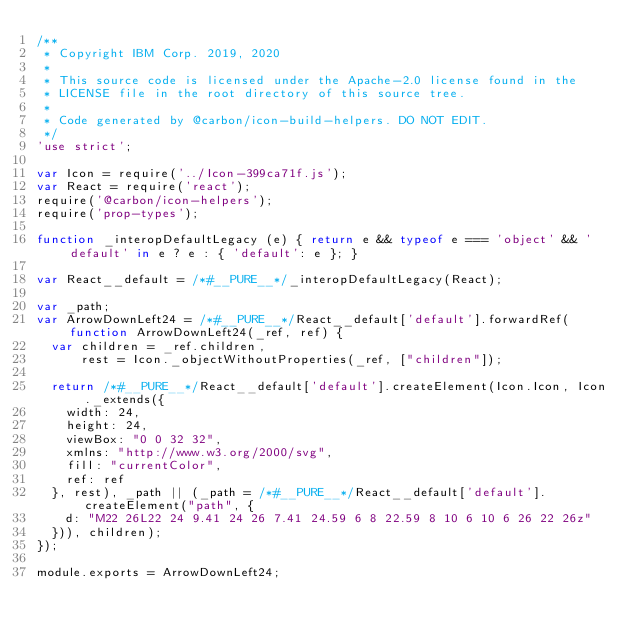Convert code to text. <code><loc_0><loc_0><loc_500><loc_500><_JavaScript_>/**
 * Copyright IBM Corp. 2019, 2020
 *
 * This source code is licensed under the Apache-2.0 license found in the
 * LICENSE file in the root directory of this source tree.
 *
 * Code generated by @carbon/icon-build-helpers. DO NOT EDIT.
 */
'use strict';

var Icon = require('../Icon-399ca71f.js');
var React = require('react');
require('@carbon/icon-helpers');
require('prop-types');

function _interopDefaultLegacy (e) { return e && typeof e === 'object' && 'default' in e ? e : { 'default': e }; }

var React__default = /*#__PURE__*/_interopDefaultLegacy(React);

var _path;
var ArrowDownLeft24 = /*#__PURE__*/React__default['default'].forwardRef(function ArrowDownLeft24(_ref, ref) {
  var children = _ref.children,
      rest = Icon._objectWithoutProperties(_ref, ["children"]);

  return /*#__PURE__*/React__default['default'].createElement(Icon.Icon, Icon._extends({
    width: 24,
    height: 24,
    viewBox: "0 0 32 32",
    xmlns: "http://www.w3.org/2000/svg",
    fill: "currentColor",
    ref: ref
  }, rest), _path || (_path = /*#__PURE__*/React__default['default'].createElement("path", {
    d: "M22 26L22 24 9.41 24 26 7.41 24.59 6 8 22.59 8 10 6 10 6 26 22 26z"
  })), children);
});

module.exports = ArrowDownLeft24;
</code> 